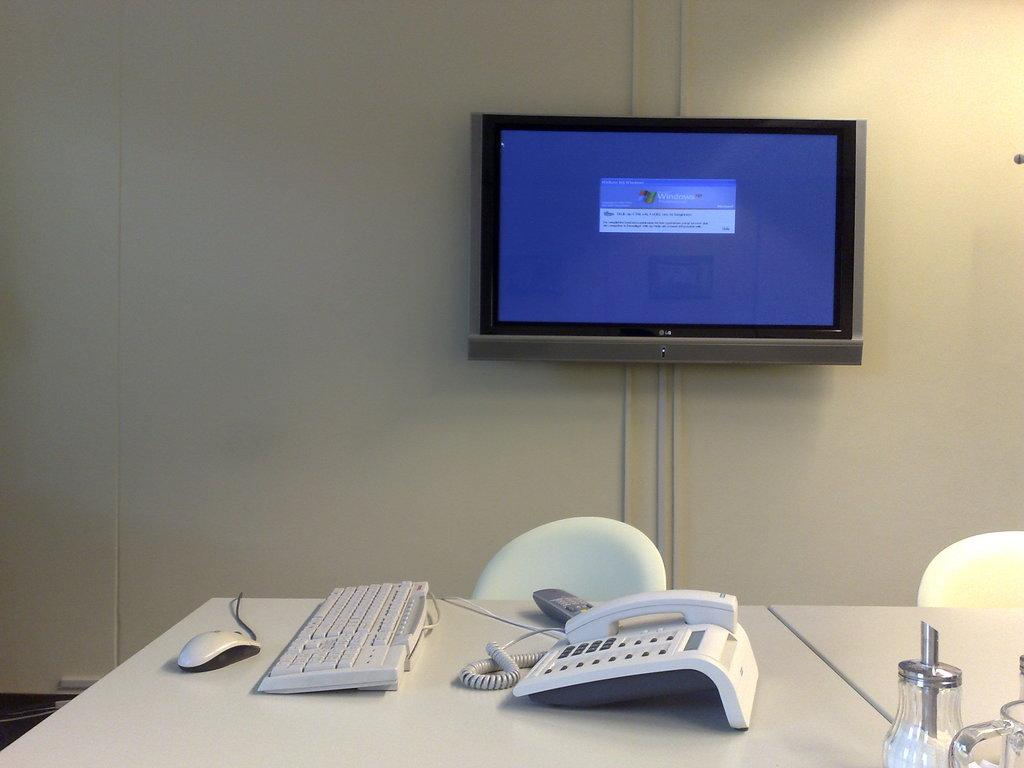Where is the monitor located in the image? The monitor is fixed to the wall in the image. What other devices are present on the table in the image? A mouse, keyboard, remote control, and telephone are present on the table in the image. How many chairs are beside the table in the image? There are two chairs beside the table in the image. What type of powder is being used to clean the monitor in the image? There is no powder present in the image, nor is there any indication of cleaning activities taking place. 